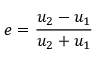Convert formula to latex. <formula><loc_0><loc_0><loc_500><loc_500>e = { \frac { u _ { 2 } - u _ { 1 } } { u _ { 2 } + u _ { 1 } } }</formula> 